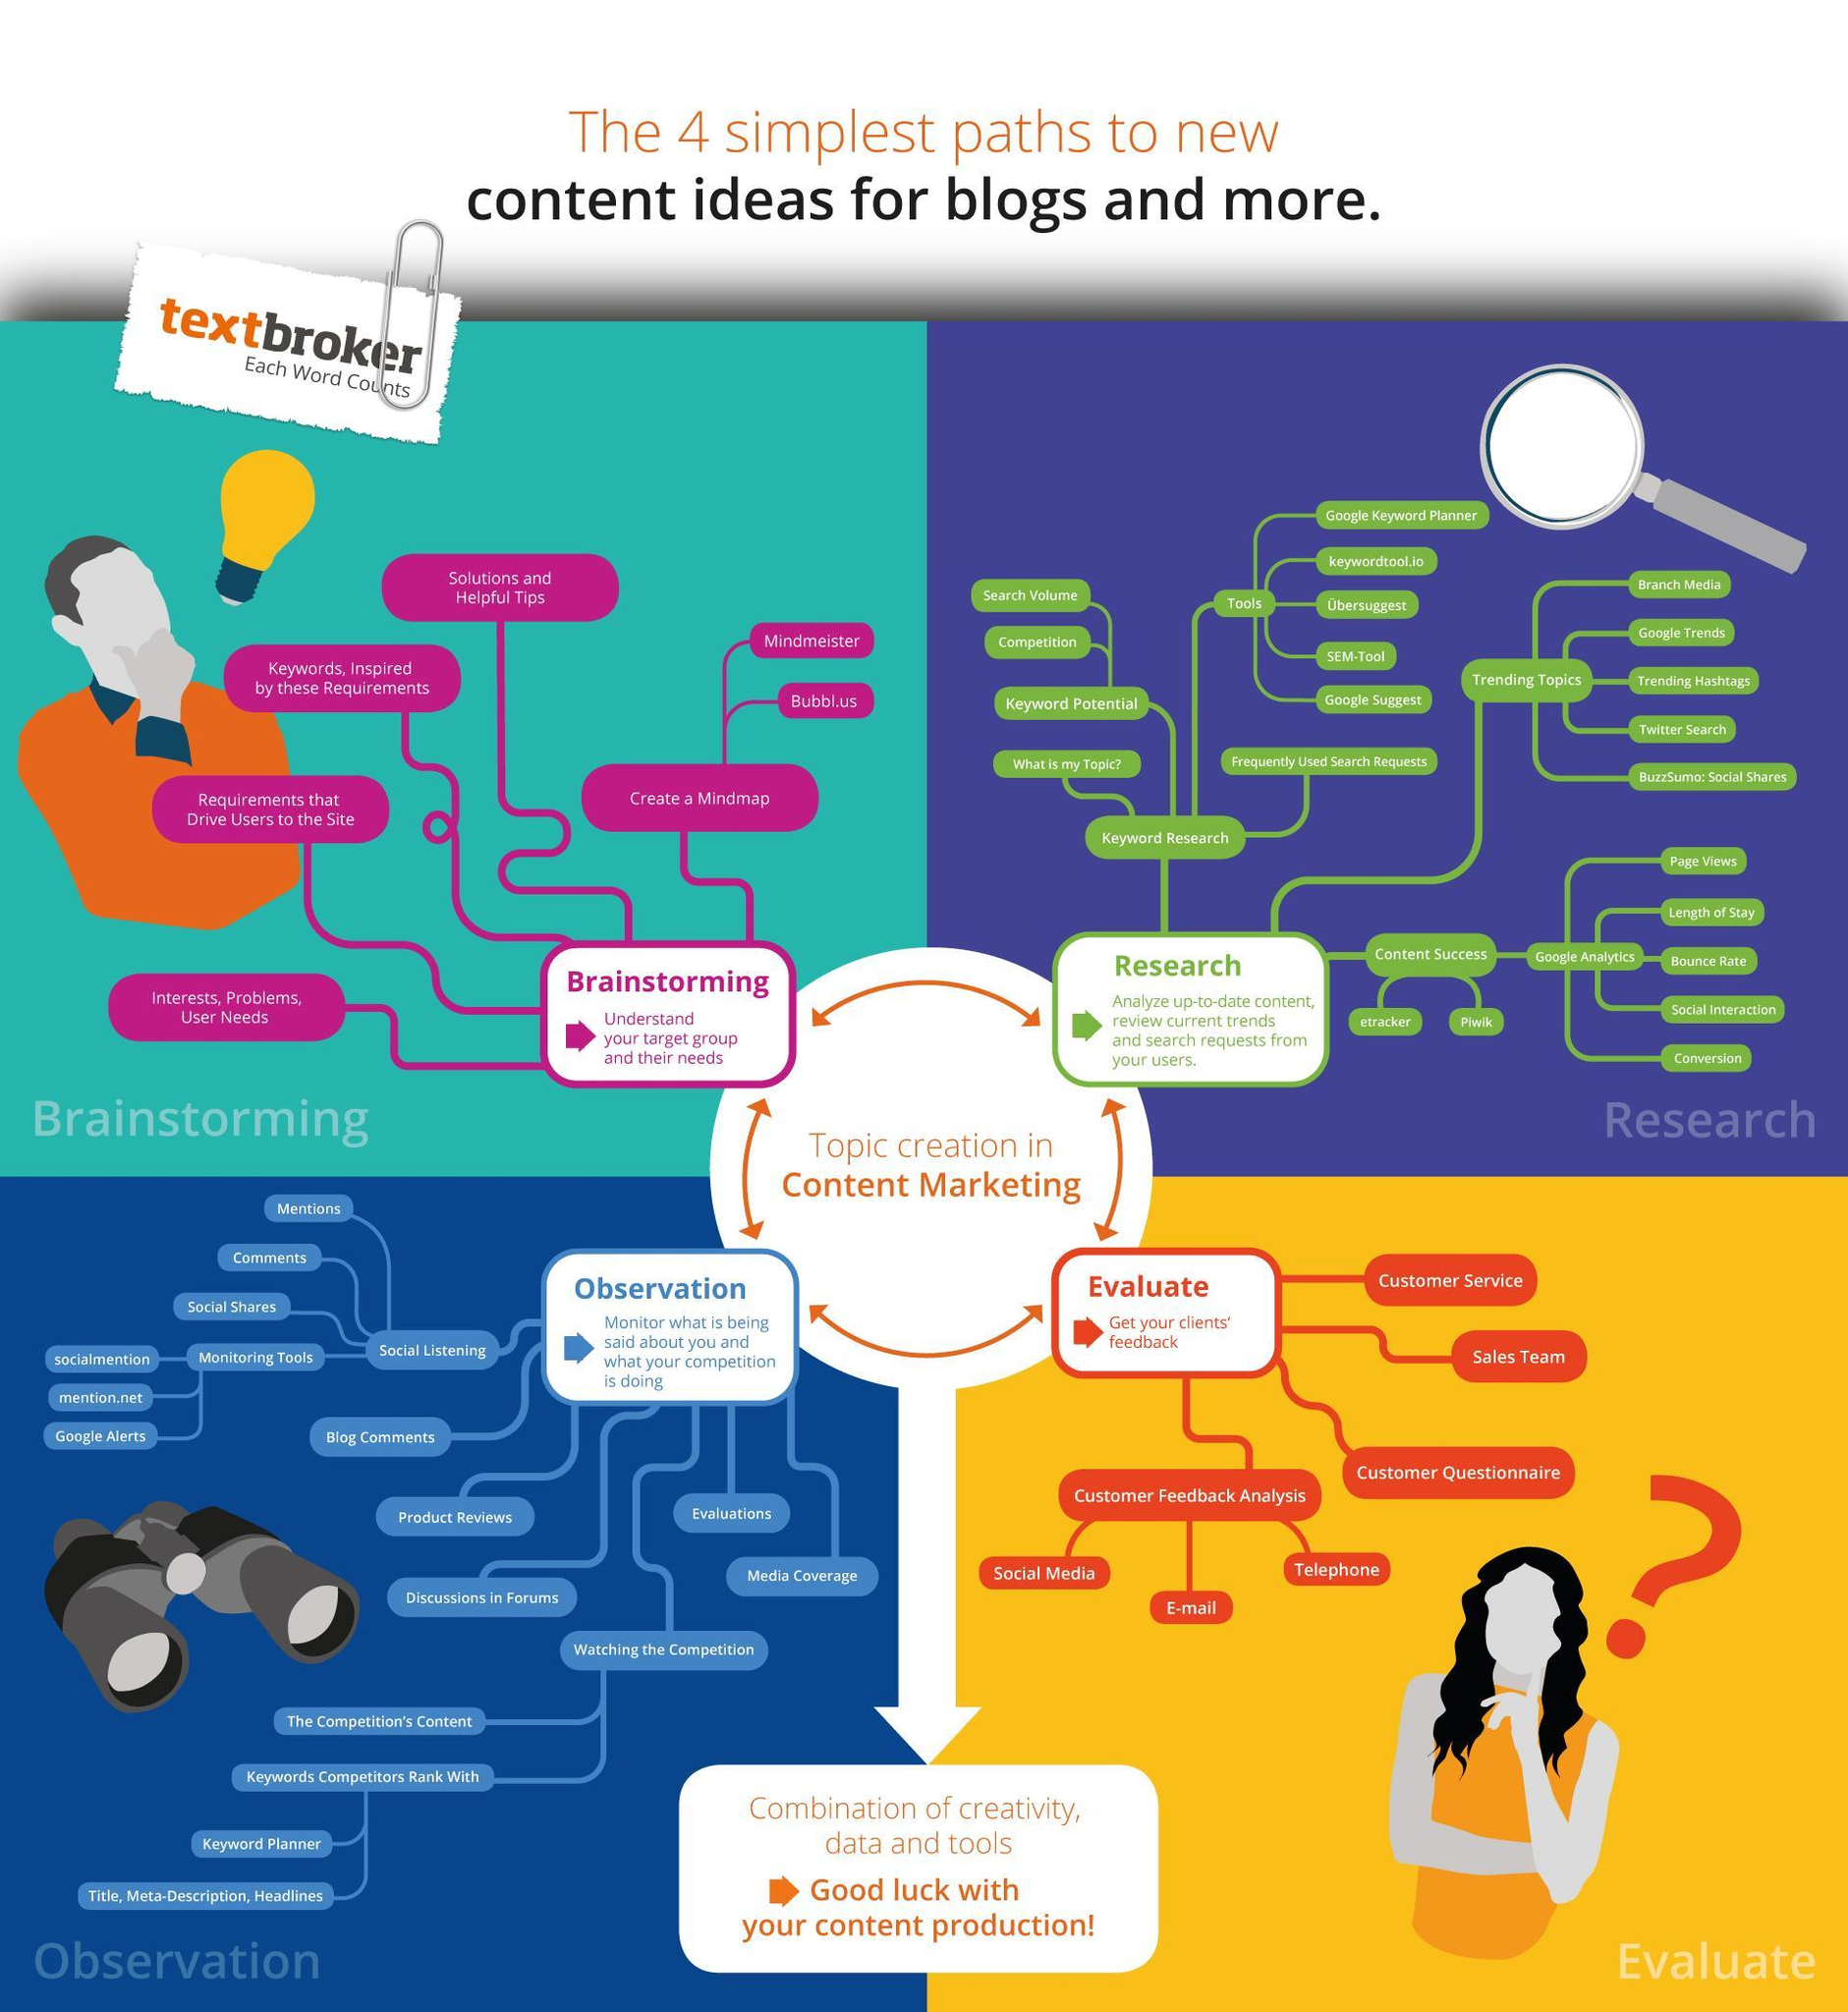Which all are the ways to analyze the success of content?
Answer the question with a short phrase. etracker, piwik Which all are the monitoring tools? socialmention, mention.net, Google alerts Which all are the ways of social listening? Mentions, Comments, Social shares Which all are the ways to create a mindmap? Mindmeister, Bubble.us Which all are the ways to get customer feedback? Media Social, Email, Telephone 